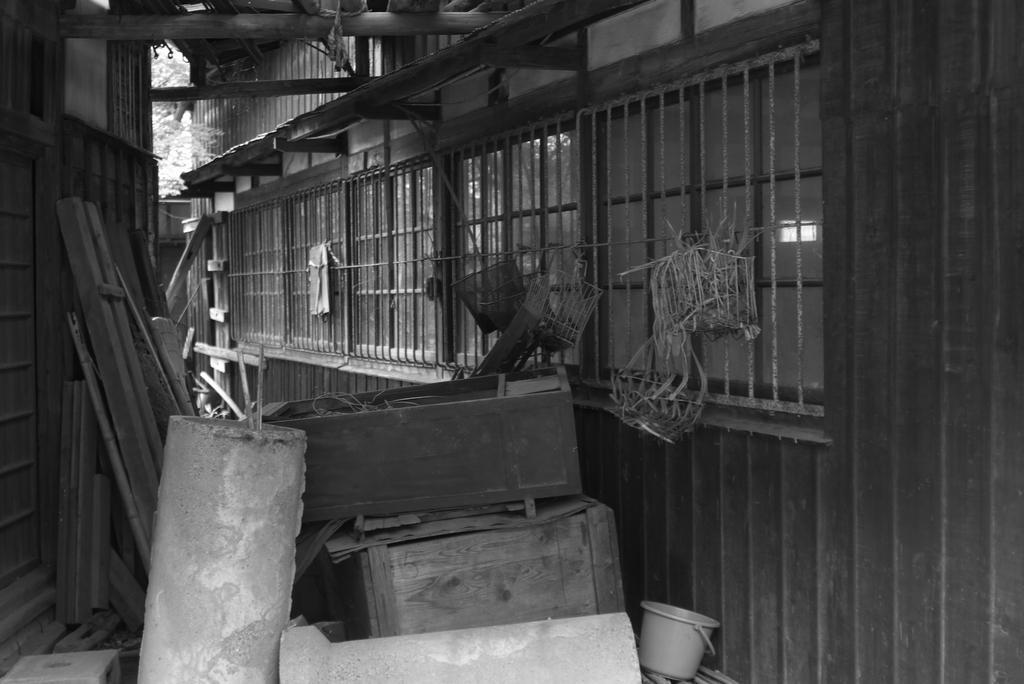Can you describe this image briefly? In this image we can see a house, windows, grille, there are some wooden objects, boxes, there is a bucket, also we can see trees, and the picture is taken in black and white mode. 